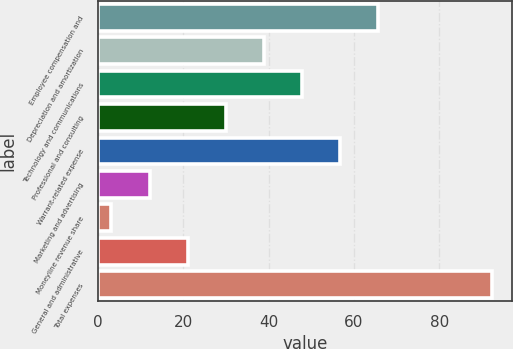<chart> <loc_0><loc_0><loc_500><loc_500><bar_chart><fcel>Employee compensation and<fcel>Depreciation and amortization<fcel>Technology and communications<fcel>Professional and consulting<fcel>Warrant-related expense<fcel>Marketing and advertising<fcel>Moneyline revenue share<fcel>General and administrative<fcel>Total expenses<nl><fcel>65.61<fcel>38.82<fcel>47.75<fcel>29.89<fcel>56.68<fcel>12.03<fcel>3.1<fcel>20.96<fcel>92.4<nl></chart> 